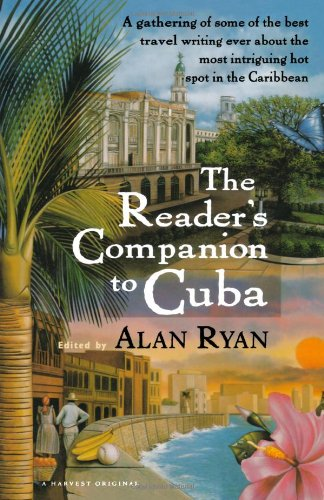What kind of stories or content might one find in a book like this? A reader can expect to find a diverse collection of travel stories and essays that delve into the rich culture, history, and landscapes of Cuba, exploring its allure as a travel destination. 